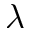<formula> <loc_0><loc_0><loc_500><loc_500>\lambda</formula> 